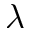<formula> <loc_0><loc_0><loc_500><loc_500>\lambda</formula> 